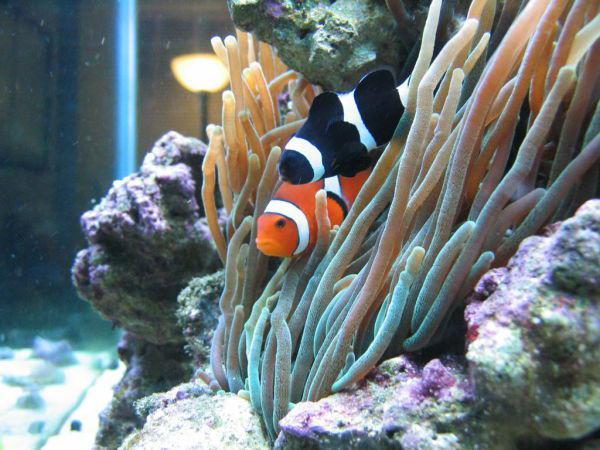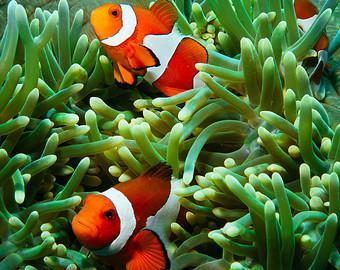The first image is the image on the left, the second image is the image on the right. Given the left and right images, does the statement "The left image contains exactly two fish, which are orange with at least one white stripe, swimming face-forward in anemone tendrils." hold true? Answer yes or no. No. The first image is the image on the left, the second image is the image on the right. Examine the images to the left and right. Is the description "The left and right image contains the same number of striped fish faces." accurate? Answer yes or no. Yes. 